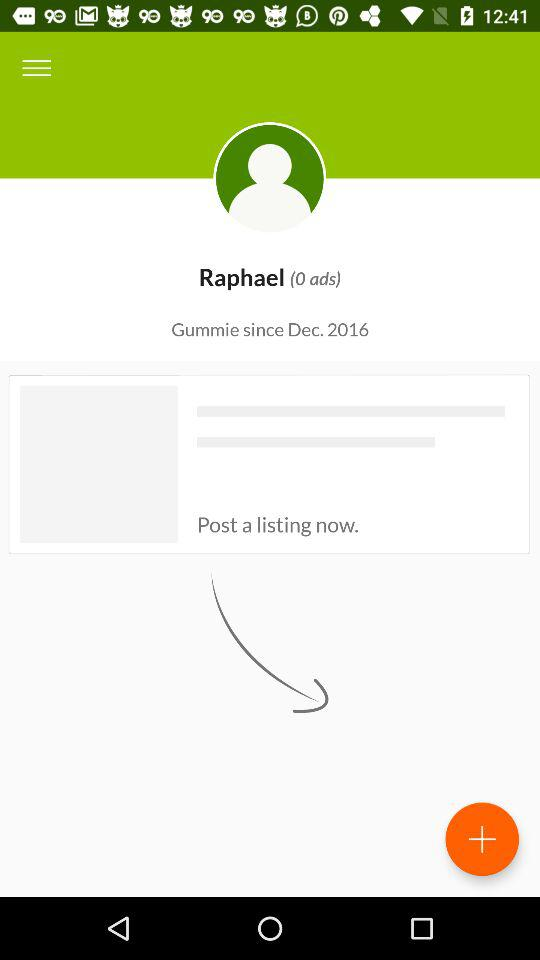From which year is the user considered Gummie? The user is considered Gummie from 2016. 